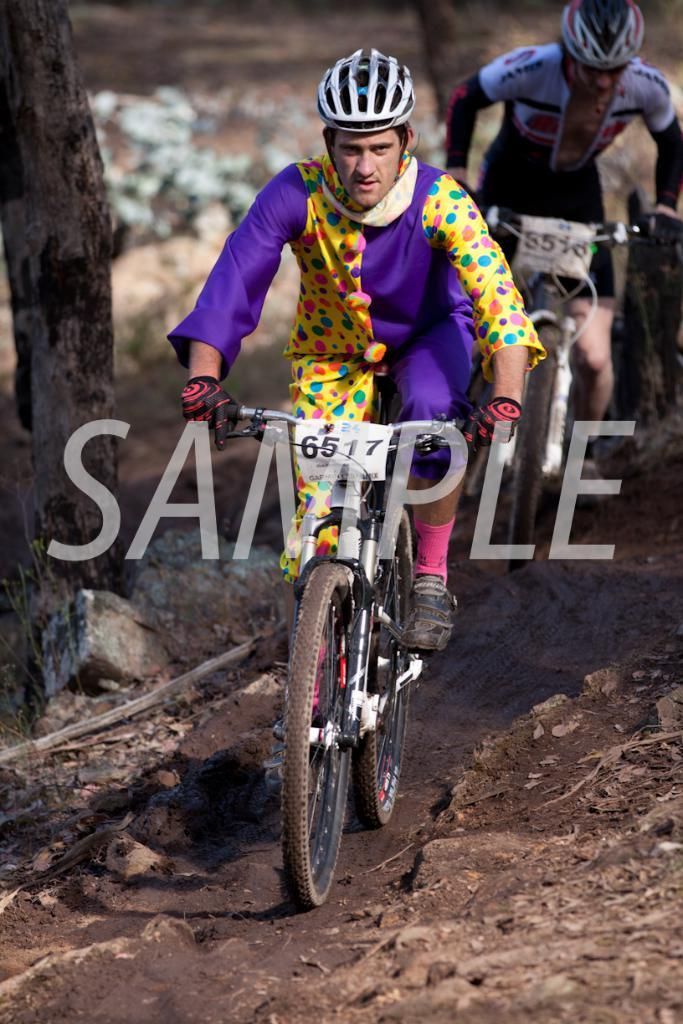How many people are in the image? There are two persons in the image. What are the persons doing in the image? The persons are riding bicycles. What can be seen on the left side of the image? There is a tree trunk on the left side of the image. What type of terrain is visible in the image? There is sand on the ground in the image. What type of arithmetic problem is being solved by the persons in the image? There is no arithmetic problem visible in the image; the persons are riding bicycles. What type of crime is being committed by the persons in the image? There is no crime being committed by the persons in the image; they are simply riding bicycles. 